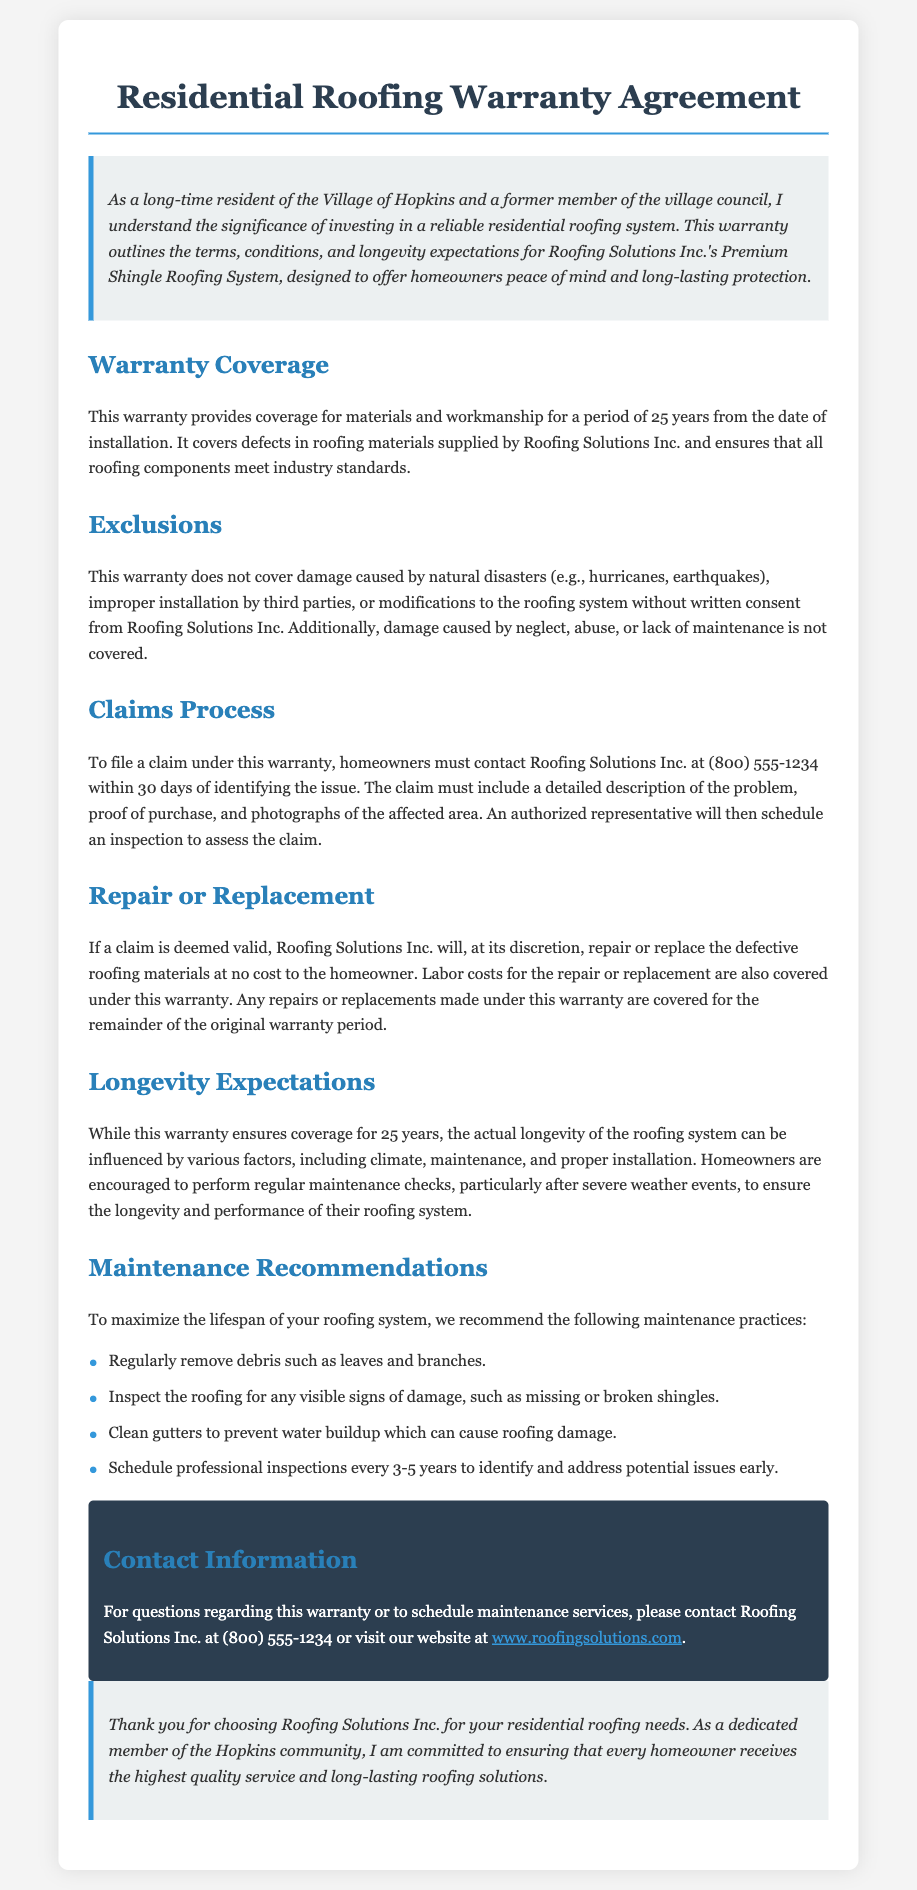What is the duration of the warranty? The warranty provides coverage for a period of 25 years from the date of installation.
Answer: 25 years What must homeowners provide to file a claim? The claim must include a detailed description of the problem, proof of purchase, and photographs of the affected area.
Answer: Description, proof of purchase, photographs Which natural disasters are excluded from the warranty coverage? The warranty does not cover damage caused by natural disasters such as hurricanes and earthquakes.
Answer: Hurricanes, earthquakes What is required for maintenance recommendations? Homeowners are encouraged to perform regular maintenance checks to ensure the longevity and performance of their roofing system.
Answer: Regular maintenance checks Who can homeowners contact with questions regarding the warranty? Homeowners can contact Roofing Solutions Inc. at (800) 555-1234 for questions regarding the warranty.
Answer: Roofing Solutions Inc What happens if the claim is valid? If a claim is deemed valid, Roofing Solutions Inc. will repair or replace the defective roofing materials at no cost to the homeowner.
Answer: Repair or replace at no cost When should professional inspections be scheduled? Professional inspections should be scheduled every 3-5 years to identify and address potential issues early.
Answer: Every 3-5 years What type of damage is not covered under the warranty? Damage caused by neglect, abuse, or lack of maintenance is not covered under the warranty.
Answer: Neglect, abuse, lack of maintenance 